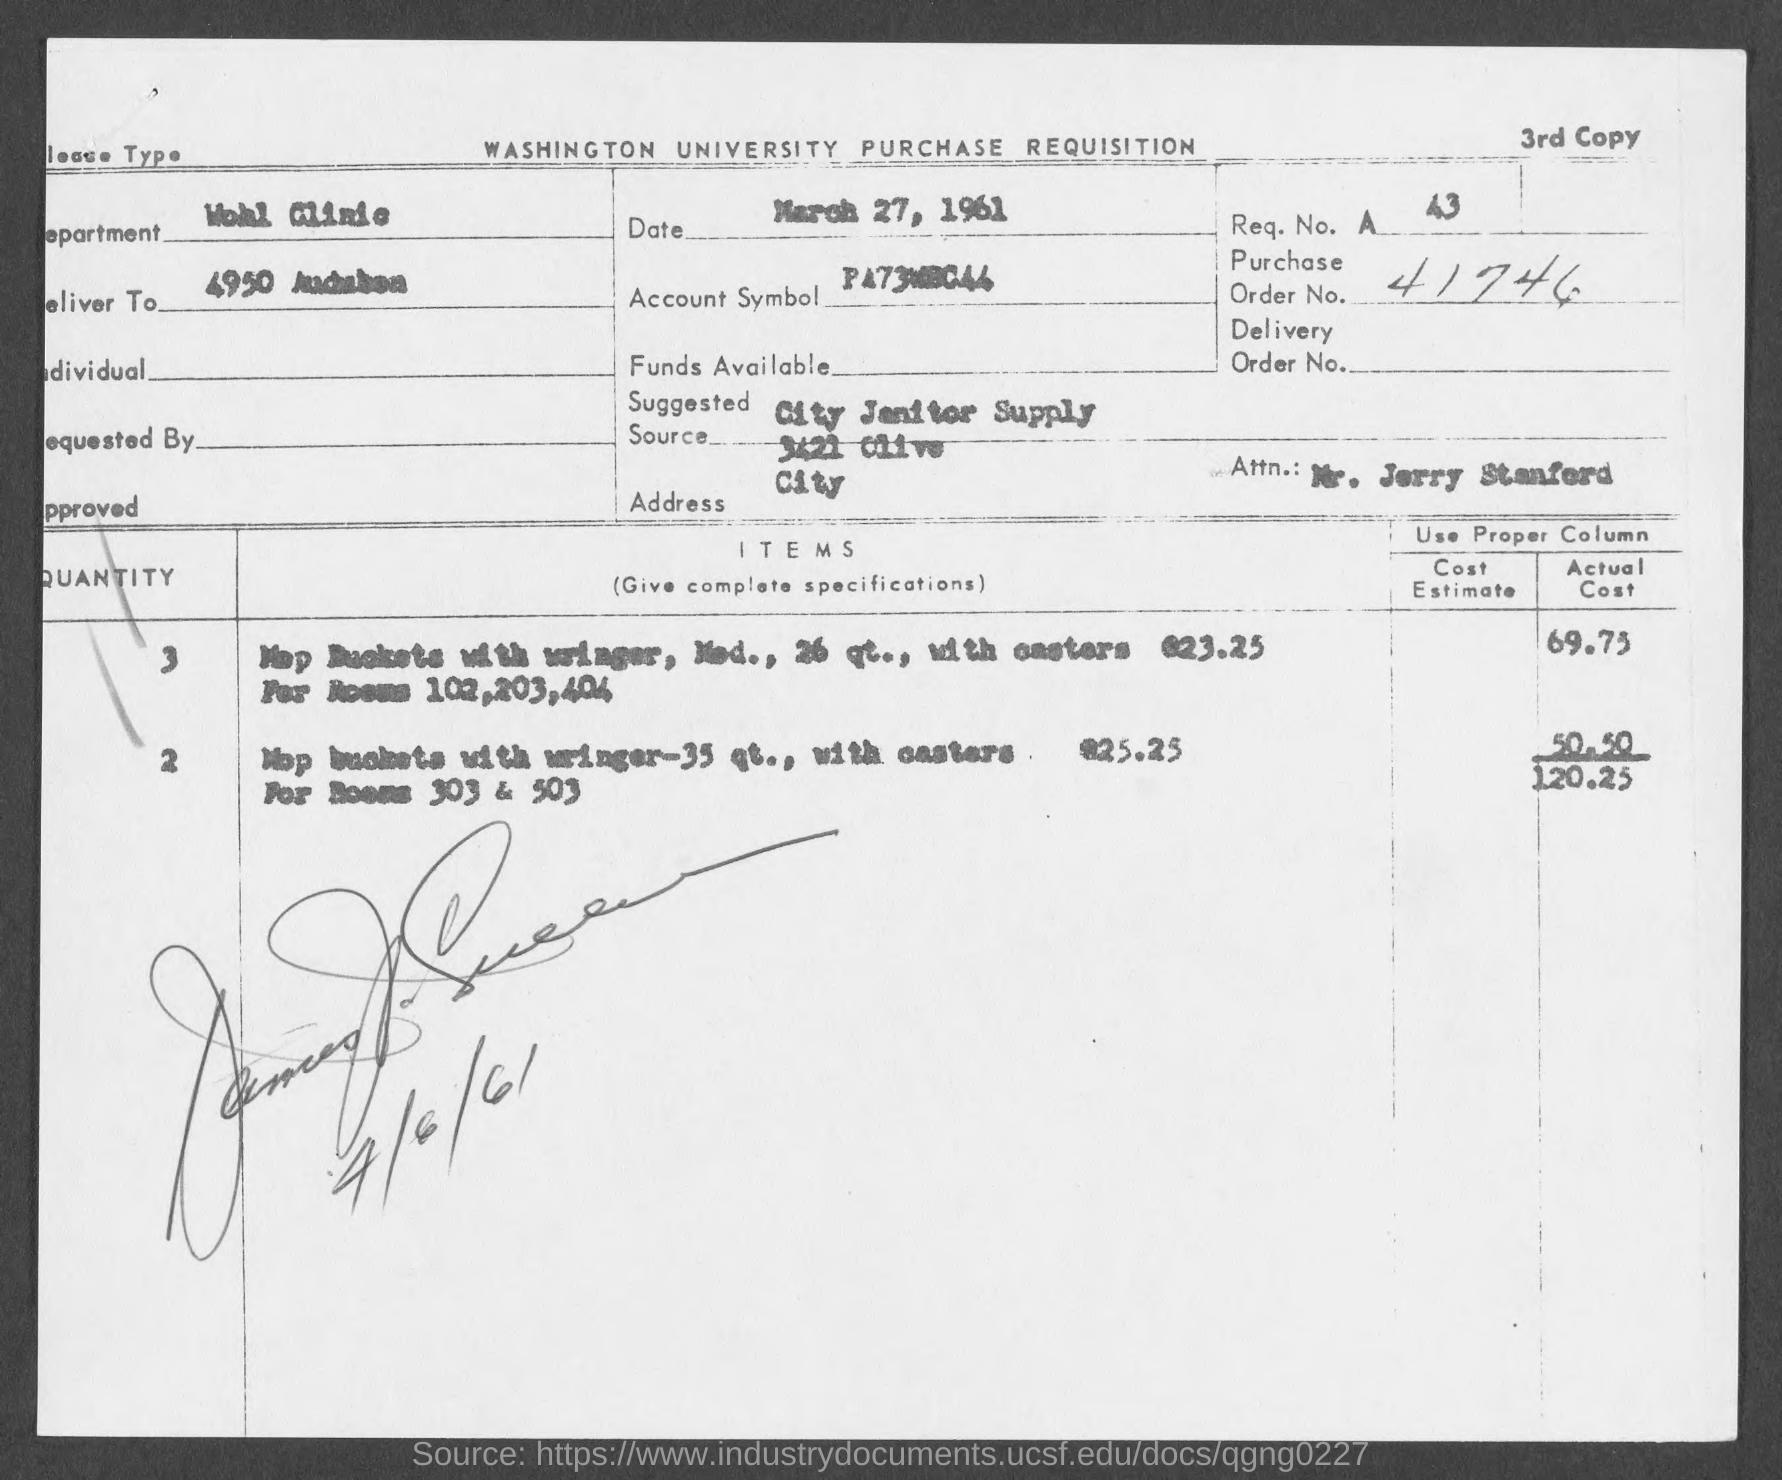Point out several critical features in this image. The purchase order number is 41746. The date given is March 27, 1961. This document pertains to a purchase requisition from Washington University. 